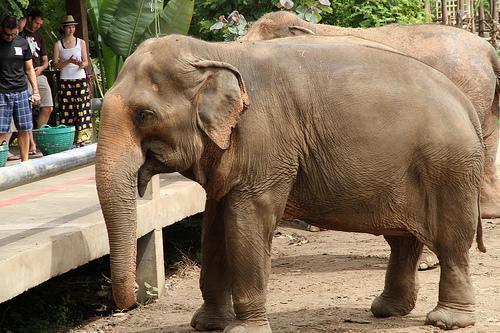How many elephants are in the picture?
Give a very brief answer. 2. How many people are in the picture?
Give a very brief answer. 3. 